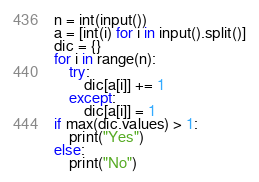<code> <loc_0><loc_0><loc_500><loc_500><_Python_>n = int(input())
a = [int(i) for i in input().split()]
dic = {}
for i in range(n):
	try:
		dic[a[i]] += 1
	except:
		dic[a[i]] = 1
if max(dic.values) > 1:
	print("Yes")
else:
  	print("No")</code> 